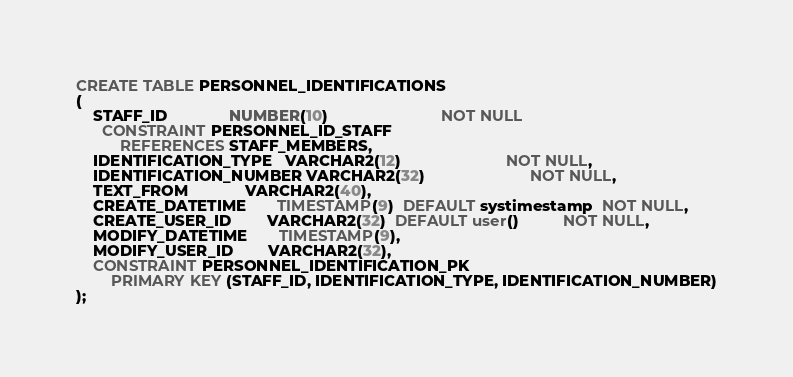Convert code to text. <code><loc_0><loc_0><loc_500><loc_500><_SQL_>CREATE TABLE PERSONNEL_IDENTIFICATIONS
(
    STAFF_ID              NUMBER(10)                          NOT NULL
      CONSTRAINT PERSONNEL_ID_STAFF
          REFERENCES STAFF_MEMBERS,
    IDENTIFICATION_TYPE   VARCHAR2(12)                        NOT NULL,
    IDENTIFICATION_NUMBER VARCHAR2(32)                        NOT NULL,
    TEXT_FROM             VARCHAR2(40),
    CREATE_DATETIME       TIMESTAMP(9)  DEFAULT systimestamp  NOT NULL,
    CREATE_USER_ID        VARCHAR2(32)  DEFAULT user()          NOT NULL,
    MODIFY_DATETIME       TIMESTAMP(9),
    MODIFY_USER_ID        VARCHAR2(32),
    CONSTRAINT PERSONNEL_IDENTIFICATION_PK
        PRIMARY KEY (STAFF_ID, IDENTIFICATION_TYPE, IDENTIFICATION_NUMBER)
);
</code> 